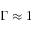<formula> <loc_0><loc_0><loc_500><loc_500>\Gamma \approx 1</formula> 